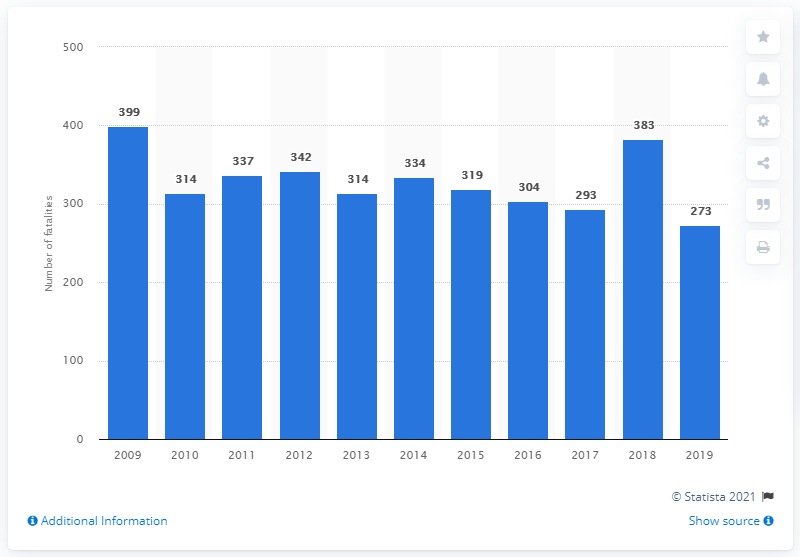Outline some significant characteristics in this image. In 2018, the number of deaths in traffic accidents in Sweden decreased. In 2019, 273 people lost their lives in traffic accidents in Sweden. 